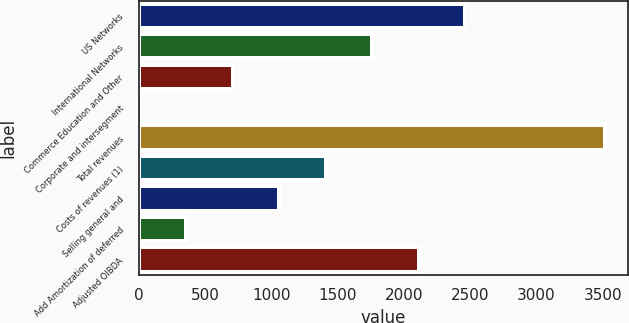Convert chart to OTSL. <chart><loc_0><loc_0><loc_500><loc_500><bar_chart><fcel>US Networks<fcel>International Networks<fcel>Commerce Education and Other<fcel>Corporate and intersegment<fcel>Total revenues<fcel>Costs of revenues (1)<fcel>Selling general and<fcel>Add Amortization of deferred<fcel>Adjusted OIBDA<nl><fcel>2463.9<fcel>1762.5<fcel>710.4<fcel>9<fcel>3516<fcel>1411.8<fcel>1061.1<fcel>359.7<fcel>2113.2<nl></chart> 